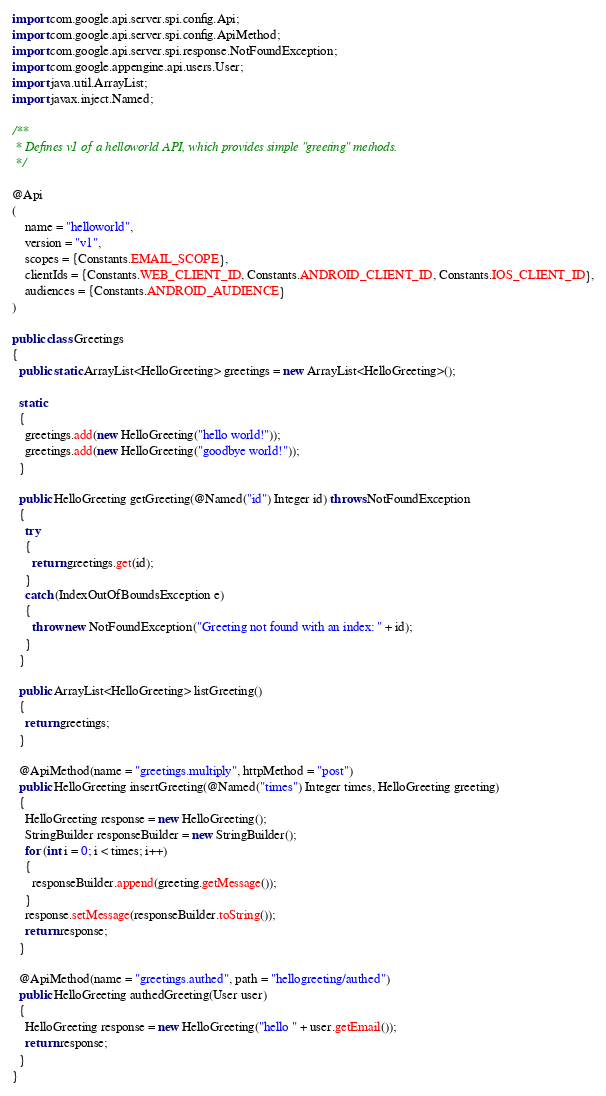<code> <loc_0><loc_0><loc_500><loc_500><_Java_>
import com.google.api.server.spi.config.Api; 
import com.google.api.server.spi.config.ApiMethod;
import com.google.api.server.spi.response.NotFoundException;
import com.google.appengine.api.users.User;
import java.util.ArrayList;
import javax.inject.Named;

/**
 * Defines v1 of a helloworld API, which provides simple "greeting" methods.
 */

@Api
(
    name = "helloworld",
    version = "v1",
    scopes = {Constants.EMAIL_SCOPE},
    clientIds = {Constants.WEB_CLIENT_ID, Constants.ANDROID_CLIENT_ID, Constants.IOS_CLIENT_ID},
    audiences = {Constants.ANDROID_AUDIENCE}
)

public class Greetings 
{
  public static ArrayList<HelloGreeting> greetings = new ArrayList<HelloGreeting>();

  static 
  {
    greetings.add(new HelloGreeting("hello world!"));
    greetings.add(new HelloGreeting("goodbye world!"));
  }

  public HelloGreeting getGreeting(@Named("id") Integer id) throws NotFoundException 
  {
    try 
    {
      return greetings.get(id);
    } 
    catch (IndexOutOfBoundsException e) 
    {
      throw new NotFoundException("Greeting not found with an index: " + id);
    }
  }

  public ArrayList<HelloGreeting> listGreeting() 
  {
    return greetings;
  }

  @ApiMethod(name = "greetings.multiply", httpMethod = "post")
  public HelloGreeting insertGreeting(@Named("times") Integer times, HelloGreeting greeting) 
  {
    HelloGreeting response = new HelloGreeting();
    StringBuilder responseBuilder = new StringBuilder();
    for (int i = 0; i < times; i++) 
    {
      responseBuilder.append(greeting.getMessage());
    }
    response.setMessage(responseBuilder.toString());
    return response;
  }

  @ApiMethod(name = "greetings.authed", path = "hellogreeting/authed")
  public HelloGreeting authedGreeting(User user) 
  {
    HelloGreeting response = new HelloGreeting("hello " + user.getEmail());
    return response;
  }
}
</code> 